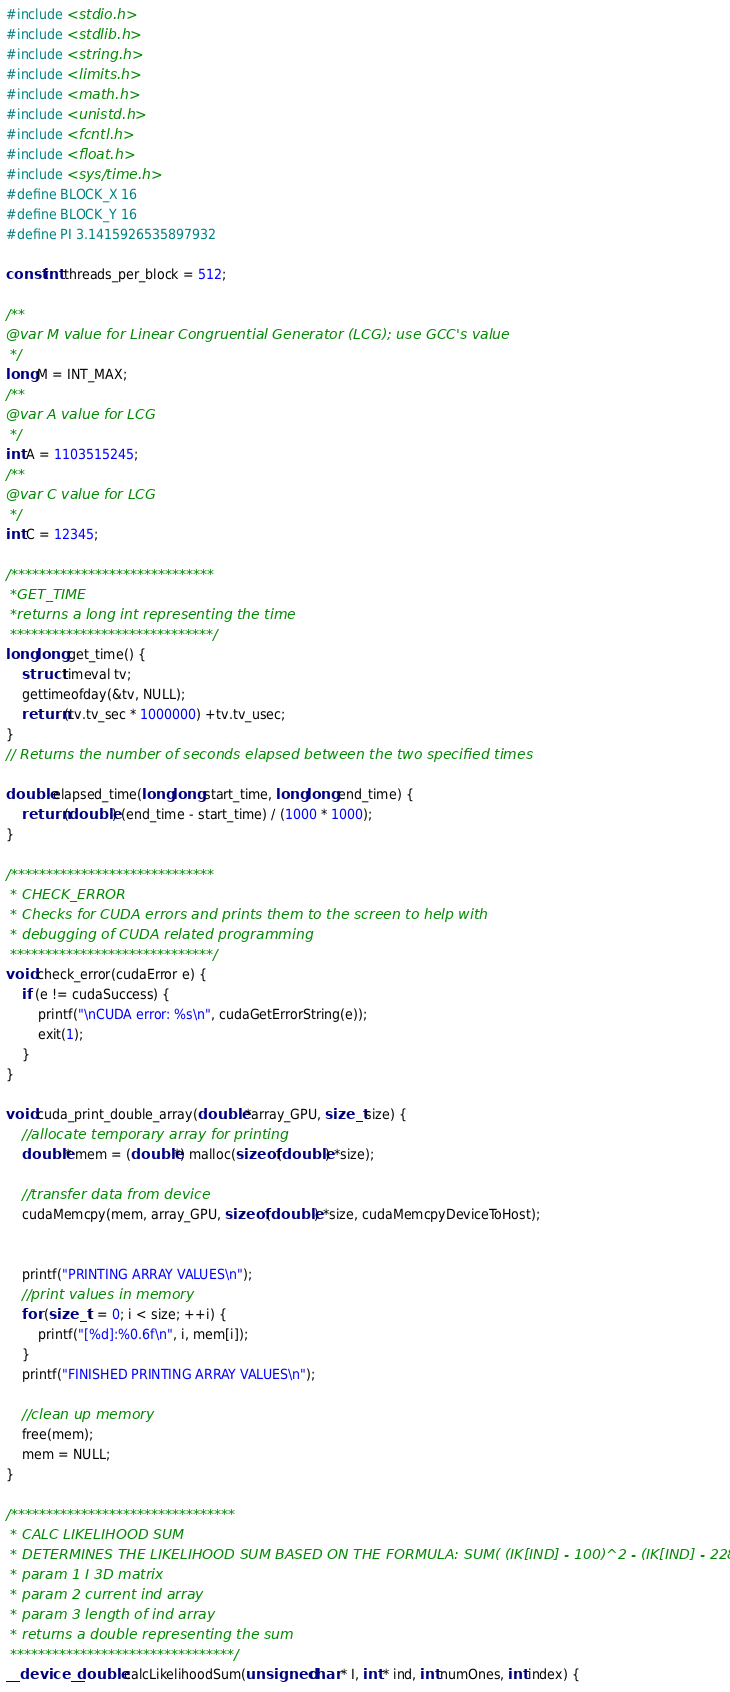<code> <loc_0><loc_0><loc_500><loc_500><_Cuda_>#include <stdio.h>
#include <stdlib.h>
#include <string.h>
#include <limits.h>
#include <math.h>
#include <unistd.h>
#include <fcntl.h>
#include <float.h>
#include <sys/time.h>
#define BLOCK_X 16
#define BLOCK_Y 16
#define PI 3.1415926535897932

const int threads_per_block = 512;

/**
@var M value for Linear Congruential Generator (LCG); use GCC's value
 */
long M = INT_MAX;
/**
@var A value for LCG
 */
int A = 1103515245;
/**
@var C value for LCG
 */
int C = 12345;

/*****************************
 *GET_TIME
 *returns a long int representing the time
 *****************************/
long long get_time() {
    struct timeval tv;
    gettimeofday(&tv, NULL);
    return (tv.tv_sec * 1000000) +tv.tv_usec;
}
// Returns the number of seconds elapsed between the two specified times

double elapsed_time(long long start_time, long long end_time) {
    return (double) (end_time - start_time) / (1000 * 1000);
}

/*****************************
 * CHECK_ERROR
 * Checks for CUDA errors and prints them to the screen to help with
 * debugging of CUDA related programming
 *****************************/
void check_error(cudaError e) {
    if (e != cudaSuccess) {
        printf("\nCUDA error: %s\n", cudaGetErrorString(e));
        exit(1);
    }
}

void cuda_print_double_array(double *array_GPU, size_t size) {
    //allocate temporary array for printing
    double* mem = (double*) malloc(sizeof (double) *size);

    //transfer data from device
    cudaMemcpy(mem, array_GPU, sizeof (double) *size, cudaMemcpyDeviceToHost);


    printf("PRINTING ARRAY VALUES\n");
    //print values in memory
    for (size_t i = 0; i < size; ++i) {
        printf("[%d]:%0.6f\n", i, mem[i]);
    }
    printf("FINISHED PRINTING ARRAY VALUES\n");

    //clean up memory
    free(mem);
    mem = NULL;
}

/********************************
 * CALC LIKELIHOOD SUM
 * DETERMINES THE LIKELIHOOD SUM BASED ON THE FORMULA: SUM( (IK[IND] - 100)^2 - (IK[IND] - 228)^2)/ 100
 * param 1 I 3D matrix
 * param 2 current ind array
 * param 3 length of ind array
 * returns a double representing the sum
 ********************************/
__device__ double calcLikelihoodSum(unsigned char * I, int * ind, int numOnes, int index) {</code> 